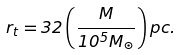Convert formula to latex. <formula><loc_0><loc_0><loc_500><loc_500>r _ { t } = 3 2 \left ( \frac { M } { 1 0 ^ { 5 } M _ { \odot } } \right ) p c .</formula> 